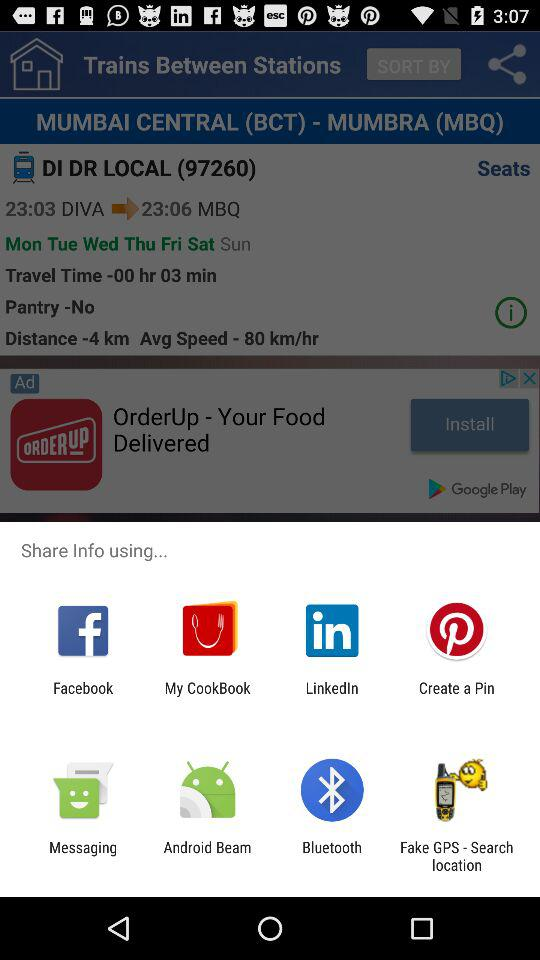What are the options to share? The options are "Facebook", "My CookBook", "LinkedIn", "Create a Pin", "Messaging", "Android Beam", "Bluetooth" and "Fake GPS - Search location". 